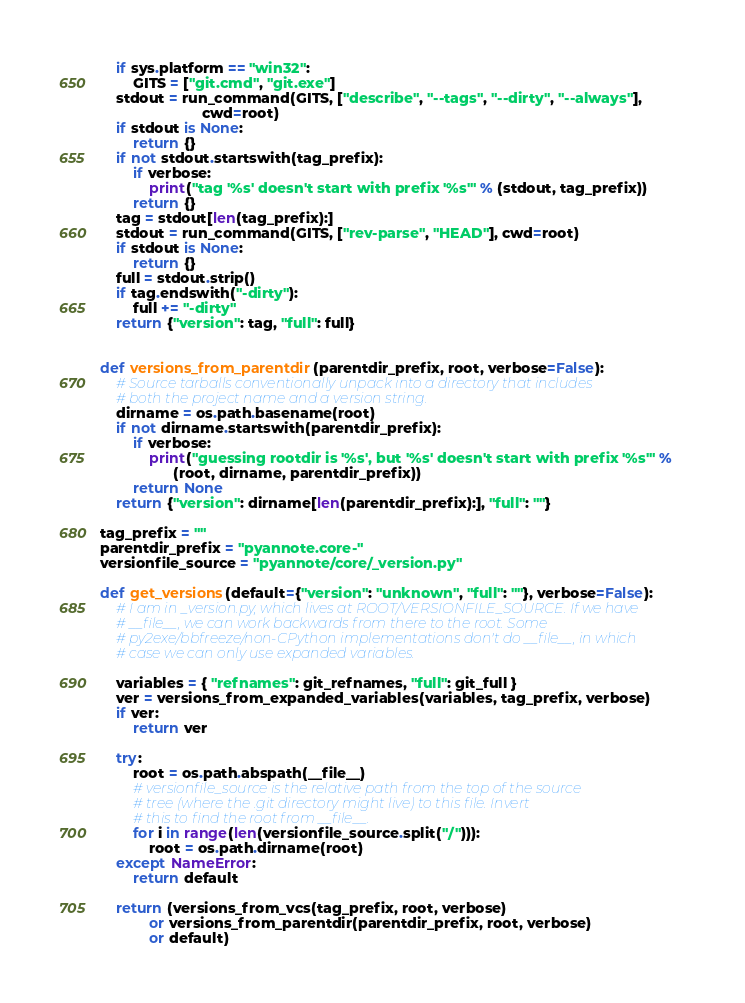Convert code to text. <code><loc_0><loc_0><loc_500><loc_500><_Python_>    if sys.platform == "win32":
        GITS = ["git.cmd", "git.exe"]
    stdout = run_command(GITS, ["describe", "--tags", "--dirty", "--always"],
                         cwd=root)
    if stdout is None:
        return {}
    if not stdout.startswith(tag_prefix):
        if verbose:
            print("tag '%s' doesn't start with prefix '%s'" % (stdout, tag_prefix))
        return {}
    tag = stdout[len(tag_prefix):]
    stdout = run_command(GITS, ["rev-parse", "HEAD"], cwd=root)
    if stdout is None:
        return {}
    full = stdout.strip()
    if tag.endswith("-dirty"):
        full += "-dirty"
    return {"version": tag, "full": full}


def versions_from_parentdir(parentdir_prefix, root, verbose=False):
    # Source tarballs conventionally unpack into a directory that includes
    # both the project name and a version string.
    dirname = os.path.basename(root)
    if not dirname.startswith(parentdir_prefix):
        if verbose:
            print("guessing rootdir is '%s', but '%s' doesn't start with prefix '%s'" %
                  (root, dirname, parentdir_prefix))
        return None
    return {"version": dirname[len(parentdir_prefix):], "full": ""}

tag_prefix = ""
parentdir_prefix = "pyannote.core-"
versionfile_source = "pyannote/core/_version.py"

def get_versions(default={"version": "unknown", "full": ""}, verbose=False):
    # I am in _version.py, which lives at ROOT/VERSIONFILE_SOURCE. If we have
    # __file__, we can work backwards from there to the root. Some
    # py2exe/bbfreeze/non-CPython implementations don't do __file__, in which
    # case we can only use expanded variables.

    variables = { "refnames": git_refnames, "full": git_full }
    ver = versions_from_expanded_variables(variables, tag_prefix, verbose)
    if ver:
        return ver

    try:
        root = os.path.abspath(__file__)
        # versionfile_source is the relative path from the top of the source
        # tree (where the .git directory might live) to this file. Invert
        # this to find the root from __file__.
        for i in range(len(versionfile_source.split("/"))):
            root = os.path.dirname(root)
    except NameError:
        return default

    return (versions_from_vcs(tag_prefix, root, verbose)
            or versions_from_parentdir(parentdir_prefix, root, verbose)
            or default)

</code> 